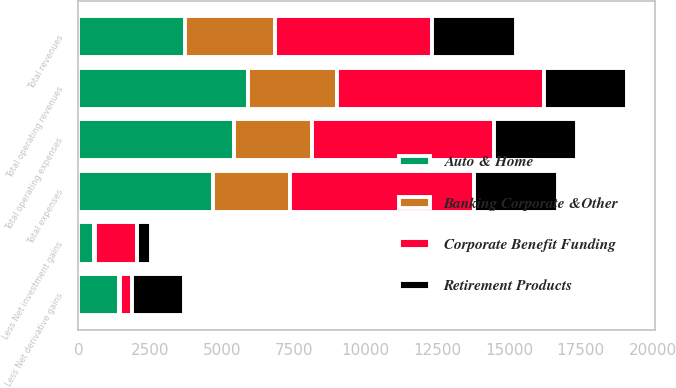Convert chart. <chart><loc_0><loc_0><loc_500><loc_500><stacked_bar_chart><ecel><fcel>Total revenues<fcel>Less Net investment gains<fcel>Less Net derivative gains<fcel>Total operating revenues<fcel>Total expenses<fcel>Total operating expenses<nl><fcel>Retirement Products<fcel>2905<fcel>472<fcel>1786<fcel>2905<fcel>2905<fcel>2905<nl><fcel>Auto & Home<fcel>3725<fcel>533<fcel>1426<fcel>5903<fcel>4690<fcel>5428<nl><fcel>Corporate Benefit Funding<fcel>5486<fcel>1486<fcel>421<fcel>7205<fcel>6400<fcel>6337<nl><fcel>Banking Corporate &Other<fcel>3113<fcel>41<fcel>39<fcel>3115<fcel>2697<fcel>2697<nl></chart> 